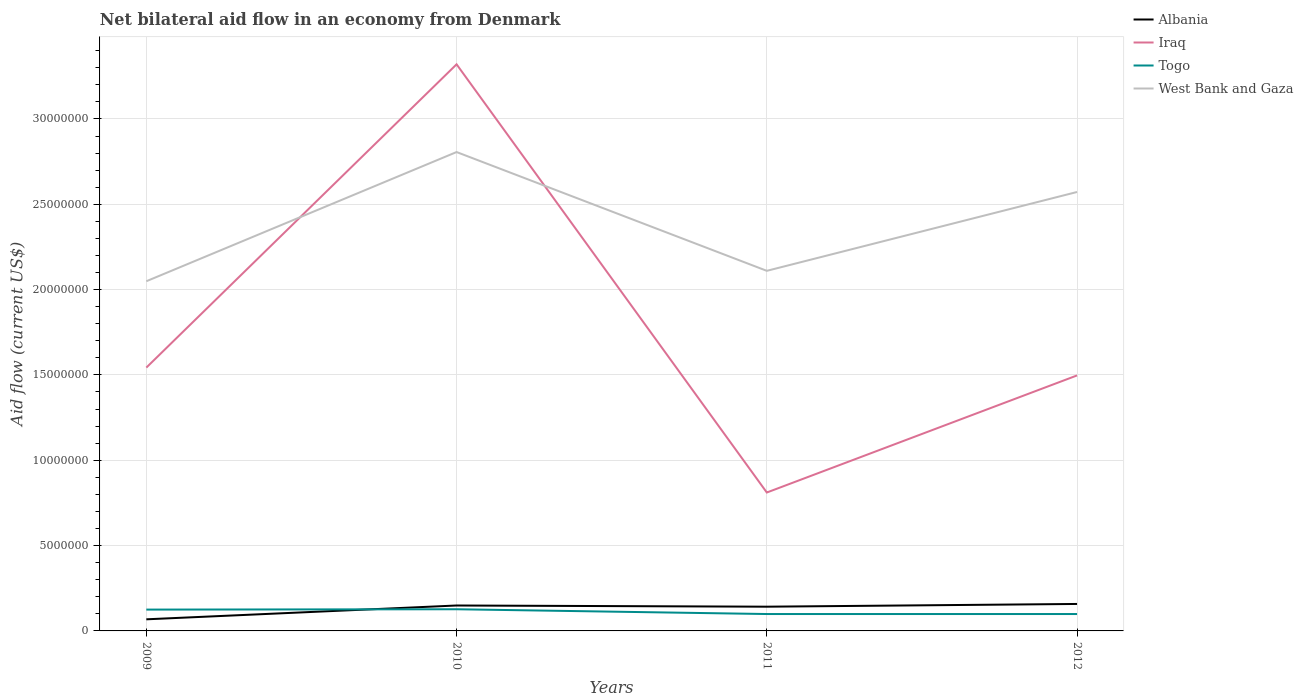How many different coloured lines are there?
Your answer should be very brief. 4. Does the line corresponding to Iraq intersect with the line corresponding to West Bank and Gaza?
Your response must be concise. Yes. Is the number of lines equal to the number of legend labels?
Your answer should be very brief. Yes. Across all years, what is the maximum net bilateral aid flow in Albania?
Ensure brevity in your answer.  6.80e+05. What is the difference between the highest and the second highest net bilateral aid flow in Iraq?
Provide a short and direct response. 2.51e+07. What is the difference between two consecutive major ticks on the Y-axis?
Provide a succinct answer. 5.00e+06. Does the graph contain grids?
Provide a short and direct response. Yes. Where does the legend appear in the graph?
Provide a short and direct response. Top right. How many legend labels are there?
Provide a succinct answer. 4. What is the title of the graph?
Ensure brevity in your answer.  Net bilateral aid flow in an economy from Denmark. What is the label or title of the Y-axis?
Your answer should be compact. Aid flow (current US$). What is the Aid flow (current US$) in Albania in 2009?
Ensure brevity in your answer.  6.80e+05. What is the Aid flow (current US$) of Iraq in 2009?
Your response must be concise. 1.54e+07. What is the Aid flow (current US$) in Togo in 2009?
Provide a succinct answer. 1.25e+06. What is the Aid flow (current US$) of West Bank and Gaza in 2009?
Offer a very short reply. 2.05e+07. What is the Aid flow (current US$) in Albania in 2010?
Make the answer very short. 1.49e+06. What is the Aid flow (current US$) of Iraq in 2010?
Ensure brevity in your answer.  3.32e+07. What is the Aid flow (current US$) of Togo in 2010?
Make the answer very short. 1.27e+06. What is the Aid flow (current US$) of West Bank and Gaza in 2010?
Provide a short and direct response. 2.81e+07. What is the Aid flow (current US$) of Albania in 2011?
Keep it short and to the point. 1.42e+06. What is the Aid flow (current US$) of Iraq in 2011?
Offer a very short reply. 8.11e+06. What is the Aid flow (current US$) in Togo in 2011?
Keep it short and to the point. 9.90e+05. What is the Aid flow (current US$) in West Bank and Gaza in 2011?
Your response must be concise. 2.11e+07. What is the Aid flow (current US$) in Albania in 2012?
Keep it short and to the point. 1.58e+06. What is the Aid flow (current US$) of Iraq in 2012?
Make the answer very short. 1.50e+07. What is the Aid flow (current US$) in Togo in 2012?
Give a very brief answer. 9.90e+05. What is the Aid flow (current US$) of West Bank and Gaza in 2012?
Offer a very short reply. 2.57e+07. Across all years, what is the maximum Aid flow (current US$) of Albania?
Provide a short and direct response. 1.58e+06. Across all years, what is the maximum Aid flow (current US$) of Iraq?
Give a very brief answer. 3.32e+07. Across all years, what is the maximum Aid flow (current US$) in Togo?
Offer a very short reply. 1.27e+06. Across all years, what is the maximum Aid flow (current US$) of West Bank and Gaza?
Offer a terse response. 2.81e+07. Across all years, what is the minimum Aid flow (current US$) in Albania?
Give a very brief answer. 6.80e+05. Across all years, what is the minimum Aid flow (current US$) in Iraq?
Offer a terse response. 8.11e+06. Across all years, what is the minimum Aid flow (current US$) of Togo?
Provide a succinct answer. 9.90e+05. Across all years, what is the minimum Aid flow (current US$) in West Bank and Gaza?
Your answer should be very brief. 2.05e+07. What is the total Aid flow (current US$) of Albania in the graph?
Your answer should be compact. 5.17e+06. What is the total Aid flow (current US$) of Iraq in the graph?
Provide a short and direct response. 7.17e+07. What is the total Aid flow (current US$) in Togo in the graph?
Your answer should be compact. 4.50e+06. What is the total Aid flow (current US$) of West Bank and Gaza in the graph?
Give a very brief answer. 9.54e+07. What is the difference between the Aid flow (current US$) of Albania in 2009 and that in 2010?
Offer a very short reply. -8.10e+05. What is the difference between the Aid flow (current US$) of Iraq in 2009 and that in 2010?
Offer a terse response. -1.78e+07. What is the difference between the Aid flow (current US$) of Togo in 2009 and that in 2010?
Provide a succinct answer. -2.00e+04. What is the difference between the Aid flow (current US$) in West Bank and Gaza in 2009 and that in 2010?
Make the answer very short. -7.57e+06. What is the difference between the Aid flow (current US$) of Albania in 2009 and that in 2011?
Provide a short and direct response. -7.40e+05. What is the difference between the Aid flow (current US$) of Iraq in 2009 and that in 2011?
Your answer should be very brief. 7.32e+06. What is the difference between the Aid flow (current US$) in West Bank and Gaza in 2009 and that in 2011?
Ensure brevity in your answer.  -6.10e+05. What is the difference between the Aid flow (current US$) in Albania in 2009 and that in 2012?
Keep it short and to the point. -9.00e+05. What is the difference between the Aid flow (current US$) in West Bank and Gaza in 2009 and that in 2012?
Your response must be concise. -5.23e+06. What is the difference between the Aid flow (current US$) in Albania in 2010 and that in 2011?
Make the answer very short. 7.00e+04. What is the difference between the Aid flow (current US$) in Iraq in 2010 and that in 2011?
Your response must be concise. 2.51e+07. What is the difference between the Aid flow (current US$) in West Bank and Gaza in 2010 and that in 2011?
Offer a very short reply. 6.96e+06. What is the difference between the Aid flow (current US$) of Albania in 2010 and that in 2012?
Ensure brevity in your answer.  -9.00e+04. What is the difference between the Aid flow (current US$) of Iraq in 2010 and that in 2012?
Provide a succinct answer. 1.82e+07. What is the difference between the Aid flow (current US$) in West Bank and Gaza in 2010 and that in 2012?
Provide a short and direct response. 2.34e+06. What is the difference between the Aid flow (current US$) in Iraq in 2011 and that in 2012?
Provide a short and direct response. -6.86e+06. What is the difference between the Aid flow (current US$) in Togo in 2011 and that in 2012?
Give a very brief answer. 0. What is the difference between the Aid flow (current US$) in West Bank and Gaza in 2011 and that in 2012?
Give a very brief answer. -4.62e+06. What is the difference between the Aid flow (current US$) in Albania in 2009 and the Aid flow (current US$) in Iraq in 2010?
Your response must be concise. -3.25e+07. What is the difference between the Aid flow (current US$) in Albania in 2009 and the Aid flow (current US$) in Togo in 2010?
Your answer should be compact. -5.90e+05. What is the difference between the Aid flow (current US$) of Albania in 2009 and the Aid flow (current US$) of West Bank and Gaza in 2010?
Provide a short and direct response. -2.74e+07. What is the difference between the Aid flow (current US$) of Iraq in 2009 and the Aid flow (current US$) of Togo in 2010?
Keep it short and to the point. 1.42e+07. What is the difference between the Aid flow (current US$) in Iraq in 2009 and the Aid flow (current US$) in West Bank and Gaza in 2010?
Your response must be concise. -1.26e+07. What is the difference between the Aid flow (current US$) of Togo in 2009 and the Aid flow (current US$) of West Bank and Gaza in 2010?
Give a very brief answer. -2.68e+07. What is the difference between the Aid flow (current US$) in Albania in 2009 and the Aid flow (current US$) in Iraq in 2011?
Offer a very short reply. -7.43e+06. What is the difference between the Aid flow (current US$) of Albania in 2009 and the Aid flow (current US$) of Togo in 2011?
Offer a very short reply. -3.10e+05. What is the difference between the Aid flow (current US$) in Albania in 2009 and the Aid flow (current US$) in West Bank and Gaza in 2011?
Give a very brief answer. -2.04e+07. What is the difference between the Aid flow (current US$) in Iraq in 2009 and the Aid flow (current US$) in Togo in 2011?
Keep it short and to the point. 1.44e+07. What is the difference between the Aid flow (current US$) in Iraq in 2009 and the Aid flow (current US$) in West Bank and Gaza in 2011?
Provide a succinct answer. -5.67e+06. What is the difference between the Aid flow (current US$) of Togo in 2009 and the Aid flow (current US$) of West Bank and Gaza in 2011?
Offer a very short reply. -1.98e+07. What is the difference between the Aid flow (current US$) of Albania in 2009 and the Aid flow (current US$) of Iraq in 2012?
Provide a succinct answer. -1.43e+07. What is the difference between the Aid flow (current US$) of Albania in 2009 and the Aid flow (current US$) of Togo in 2012?
Provide a succinct answer. -3.10e+05. What is the difference between the Aid flow (current US$) of Albania in 2009 and the Aid flow (current US$) of West Bank and Gaza in 2012?
Your response must be concise. -2.50e+07. What is the difference between the Aid flow (current US$) in Iraq in 2009 and the Aid flow (current US$) in Togo in 2012?
Your answer should be compact. 1.44e+07. What is the difference between the Aid flow (current US$) in Iraq in 2009 and the Aid flow (current US$) in West Bank and Gaza in 2012?
Keep it short and to the point. -1.03e+07. What is the difference between the Aid flow (current US$) in Togo in 2009 and the Aid flow (current US$) in West Bank and Gaza in 2012?
Keep it short and to the point. -2.45e+07. What is the difference between the Aid flow (current US$) of Albania in 2010 and the Aid flow (current US$) of Iraq in 2011?
Provide a succinct answer. -6.62e+06. What is the difference between the Aid flow (current US$) in Albania in 2010 and the Aid flow (current US$) in Togo in 2011?
Offer a very short reply. 5.00e+05. What is the difference between the Aid flow (current US$) of Albania in 2010 and the Aid flow (current US$) of West Bank and Gaza in 2011?
Provide a short and direct response. -1.96e+07. What is the difference between the Aid flow (current US$) in Iraq in 2010 and the Aid flow (current US$) in Togo in 2011?
Your response must be concise. 3.22e+07. What is the difference between the Aid flow (current US$) of Iraq in 2010 and the Aid flow (current US$) of West Bank and Gaza in 2011?
Offer a very short reply. 1.21e+07. What is the difference between the Aid flow (current US$) of Togo in 2010 and the Aid flow (current US$) of West Bank and Gaza in 2011?
Offer a terse response. -1.98e+07. What is the difference between the Aid flow (current US$) of Albania in 2010 and the Aid flow (current US$) of Iraq in 2012?
Provide a short and direct response. -1.35e+07. What is the difference between the Aid flow (current US$) of Albania in 2010 and the Aid flow (current US$) of Togo in 2012?
Provide a short and direct response. 5.00e+05. What is the difference between the Aid flow (current US$) in Albania in 2010 and the Aid flow (current US$) in West Bank and Gaza in 2012?
Provide a short and direct response. -2.42e+07. What is the difference between the Aid flow (current US$) in Iraq in 2010 and the Aid flow (current US$) in Togo in 2012?
Provide a succinct answer. 3.22e+07. What is the difference between the Aid flow (current US$) in Iraq in 2010 and the Aid flow (current US$) in West Bank and Gaza in 2012?
Provide a succinct answer. 7.48e+06. What is the difference between the Aid flow (current US$) in Togo in 2010 and the Aid flow (current US$) in West Bank and Gaza in 2012?
Provide a short and direct response. -2.44e+07. What is the difference between the Aid flow (current US$) of Albania in 2011 and the Aid flow (current US$) of Iraq in 2012?
Provide a short and direct response. -1.36e+07. What is the difference between the Aid flow (current US$) in Albania in 2011 and the Aid flow (current US$) in West Bank and Gaza in 2012?
Provide a succinct answer. -2.43e+07. What is the difference between the Aid flow (current US$) of Iraq in 2011 and the Aid flow (current US$) of Togo in 2012?
Offer a terse response. 7.12e+06. What is the difference between the Aid flow (current US$) in Iraq in 2011 and the Aid flow (current US$) in West Bank and Gaza in 2012?
Offer a very short reply. -1.76e+07. What is the difference between the Aid flow (current US$) in Togo in 2011 and the Aid flow (current US$) in West Bank and Gaza in 2012?
Keep it short and to the point. -2.47e+07. What is the average Aid flow (current US$) of Albania per year?
Provide a succinct answer. 1.29e+06. What is the average Aid flow (current US$) in Iraq per year?
Offer a very short reply. 1.79e+07. What is the average Aid flow (current US$) of Togo per year?
Make the answer very short. 1.12e+06. What is the average Aid flow (current US$) of West Bank and Gaza per year?
Your answer should be very brief. 2.38e+07. In the year 2009, what is the difference between the Aid flow (current US$) in Albania and Aid flow (current US$) in Iraq?
Provide a succinct answer. -1.48e+07. In the year 2009, what is the difference between the Aid flow (current US$) of Albania and Aid flow (current US$) of Togo?
Your answer should be very brief. -5.70e+05. In the year 2009, what is the difference between the Aid flow (current US$) in Albania and Aid flow (current US$) in West Bank and Gaza?
Provide a short and direct response. -1.98e+07. In the year 2009, what is the difference between the Aid flow (current US$) in Iraq and Aid flow (current US$) in Togo?
Provide a short and direct response. 1.42e+07. In the year 2009, what is the difference between the Aid flow (current US$) of Iraq and Aid flow (current US$) of West Bank and Gaza?
Make the answer very short. -5.06e+06. In the year 2009, what is the difference between the Aid flow (current US$) in Togo and Aid flow (current US$) in West Bank and Gaza?
Make the answer very short. -1.92e+07. In the year 2010, what is the difference between the Aid flow (current US$) in Albania and Aid flow (current US$) in Iraq?
Provide a short and direct response. -3.17e+07. In the year 2010, what is the difference between the Aid flow (current US$) of Albania and Aid flow (current US$) of Togo?
Offer a terse response. 2.20e+05. In the year 2010, what is the difference between the Aid flow (current US$) of Albania and Aid flow (current US$) of West Bank and Gaza?
Offer a terse response. -2.66e+07. In the year 2010, what is the difference between the Aid flow (current US$) in Iraq and Aid flow (current US$) in Togo?
Your answer should be very brief. 3.19e+07. In the year 2010, what is the difference between the Aid flow (current US$) of Iraq and Aid flow (current US$) of West Bank and Gaza?
Give a very brief answer. 5.14e+06. In the year 2010, what is the difference between the Aid flow (current US$) of Togo and Aid flow (current US$) of West Bank and Gaza?
Your answer should be very brief. -2.68e+07. In the year 2011, what is the difference between the Aid flow (current US$) in Albania and Aid flow (current US$) in Iraq?
Ensure brevity in your answer.  -6.69e+06. In the year 2011, what is the difference between the Aid flow (current US$) of Albania and Aid flow (current US$) of Togo?
Make the answer very short. 4.30e+05. In the year 2011, what is the difference between the Aid flow (current US$) of Albania and Aid flow (current US$) of West Bank and Gaza?
Ensure brevity in your answer.  -1.97e+07. In the year 2011, what is the difference between the Aid flow (current US$) in Iraq and Aid flow (current US$) in Togo?
Keep it short and to the point. 7.12e+06. In the year 2011, what is the difference between the Aid flow (current US$) of Iraq and Aid flow (current US$) of West Bank and Gaza?
Your answer should be compact. -1.30e+07. In the year 2011, what is the difference between the Aid flow (current US$) in Togo and Aid flow (current US$) in West Bank and Gaza?
Make the answer very short. -2.01e+07. In the year 2012, what is the difference between the Aid flow (current US$) of Albania and Aid flow (current US$) of Iraq?
Provide a short and direct response. -1.34e+07. In the year 2012, what is the difference between the Aid flow (current US$) of Albania and Aid flow (current US$) of Togo?
Provide a short and direct response. 5.90e+05. In the year 2012, what is the difference between the Aid flow (current US$) of Albania and Aid flow (current US$) of West Bank and Gaza?
Offer a very short reply. -2.41e+07. In the year 2012, what is the difference between the Aid flow (current US$) in Iraq and Aid flow (current US$) in Togo?
Provide a short and direct response. 1.40e+07. In the year 2012, what is the difference between the Aid flow (current US$) in Iraq and Aid flow (current US$) in West Bank and Gaza?
Your answer should be very brief. -1.08e+07. In the year 2012, what is the difference between the Aid flow (current US$) of Togo and Aid flow (current US$) of West Bank and Gaza?
Offer a terse response. -2.47e+07. What is the ratio of the Aid flow (current US$) in Albania in 2009 to that in 2010?
Offer a terse response. 0.46. What is the ratio of the Aid flow (current US$) in Iraq in 2009 to that in 2010?
Your answer should be very brief. 0.46. What is the ratio of the Aid flow (current US$) in Togo in 2009 to that in 2010?
Ensure brevity in your answer.  0.98. What is the ratio of the Aid flow (current US$) in West Bank and Gaza in 2009 to that in 2010?
Your answer should be very brief. 0.73. What is the ratio of the Aid flow (current US$) in Albania in 2009 to that in 2011?
Make the answer very short. 0.48. What is the ratio of the Aid flow (current US$) in Iraq in 2009 to that in 2011?
Ensure brevity in your answer.  1.9. What is the ratio of the Aid flow (current US$) of Togo in 2009 to that in 2011?
Offer a terse response. 1.26. What is the ratio of the Aid flow (current US$) in West Bank and Gaza in 2009 to that in 2011?
Give a very brief answer. 0.97. What is the ratio of the Aid flow (current US$) in Albania in 2009 to that in 2012?
Offer a very short reply. 0.43. What is the ratio of the Aid flow (current US$) of Iraq in 2009 to that in 2012?
Ensure brevity in your answer.  1.03. What is the ratio of the Aid flow (current US$) of Togo in 2009 to that in 2012?
Provide a succinct answer. 1.26. What is the ratio of the Aid flow (current US$) in West Bank and Gaza in 2009 to that in 2012?
Your answer should be compact. 0.8. What is the ratio of the Aid flow (current US$) in Albania in 2010 to that in 2011?
Provide a succinct answer. 1.05. What is the ratio of the Aid flow (current US$) in Iraq in 2010 to that in 2011?
Offer a terse response. 4.09. What is the ratio of the Aid flow (current US$) of Togo in 2010 to that in 2011?
Your answer should be very brief. 1.28. What is the ratio of the Aid flow (current US$) of West Bank and Gaza in 2010 to that in 2011?
Make the answer very short. 1.33. What is the ratio of the Aid flow (current US$) in Albania in 2010 to that in 2012?
Provide a succinct answer. 0.94. What is the ratio of the Aid flow (current US$) in Iraq in 2010 to that in 2012?
Your answer should be compact. 2.22. What is the ratio of the Aid flow (current US$) of Togo in 2010 to that in 2012?
Provide a succinct answer. 1.28. What is the ratio of the Aid flow (current US$) in West Bank and Gaza in 2010 to that in 2012?
Ensure brevity in your answer.  1.09. What is the ratio of the Aid flow (current US$) of Albania in 2011 to that in 2012?
Your answer should be very brief. 0.9. What is the ratio of the Aid flow (current US$) of Iraq in 2011 to that in 2012?
Give a very brief answer. 0.54. What is the ratio of the Aid flow (current US$) in Togo in 2011 to that in 2012?
Give a very brief answer. 1. What is the ratio of the Aid flow (current US$) of West Bank and Gaza in 2011 to that in 2012?
Your answer should be compact. 0.82. What is the difference between the highest and the second highest Aid flow (current US$) in Albania?
Your answer should be very brief. 9.00e+04. What is the difference between the highest and the second highest Aid flow (current US$) in Iraq?
Give a very brief answer. 1.78e+07. What is the difference between the highest and the second highest Aid flow (current US$) of Togo?
Give a very brief answer. 2.00e+04. What is the difference between the highest and the second highest Aid flow (current US$) of West Bank and Gaza?
Make the answer very short. 2.34e+06. What is the difference between the highest and the lowest Aid flow (current US$) of Albania?
Your answer should be compact. 9.00e+05. What is the difference between the highest and the lowest Aid flow (current US$) in Iraq?
Offer a terse response. 2.51e+07. What is the difference between the highest and the lowest Aid flow (current US$) in West Bank and Gaza?
Ensure brevity in your answer.  7.57e+06. 